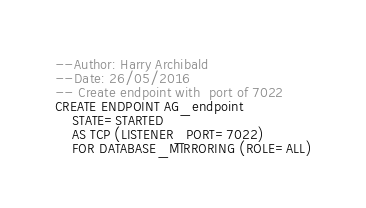Convert code to text. <code><loc_0><loc_0><loc_500><loc_500><_SQL_>--Author: Harry Archibald
--Date: 26/05/2016
-- Create endpoint with  port of 7022
CREATE ENDPOINT AG_endpoint
    STATE=STARTED 
    AS TCP (LISTENER_PORT=7022) 
    FOR DATABASE_MIRRORING (ROLE=ALL)</code> 